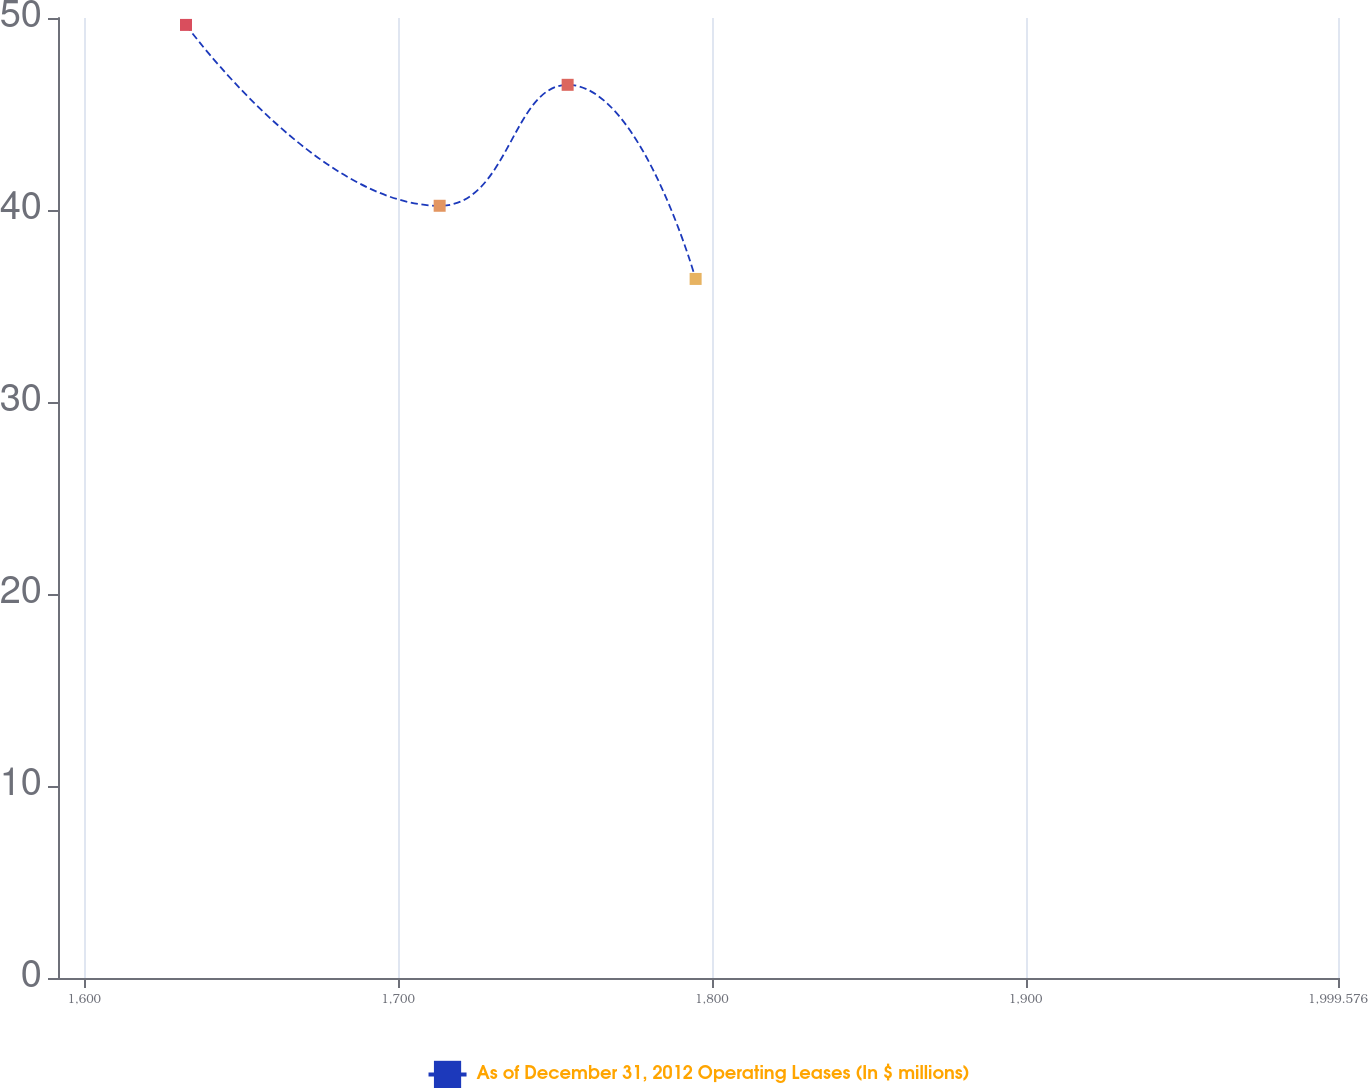Convert chart to OTSL. <chart><loc_0><loc_0><loc_500><loc_500><line_chart><ecel><fcel>As of December 31, 2012 Operating Leases (In $ millions)<nl><fcel>1632.43<fcel>49.64<nl><fcel>1713.27<fcel>40.22<nl><fcel>1754.06<fcel>46.52<nl><fcel>1794.85<fcel>36.41<nl><fcel>2040.37<fcel>17.87<nl></chart> 